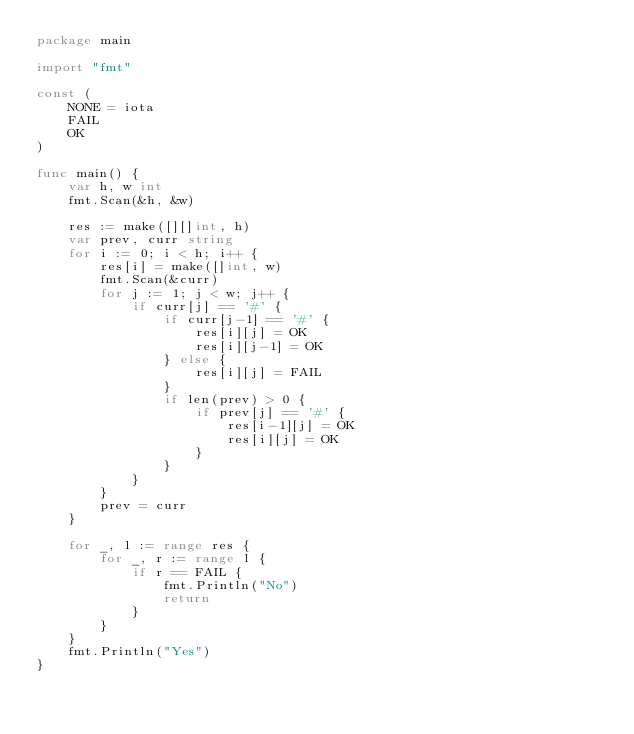<code> <loc_0><loc_0><loc_500><loc_500><_Go_>package main

import "fmt"

const (
	NONE = iota
	FAIL
	OK
)

func main() {
	var h, w int
	fmt.Scan(&h, &w)

	res := make([][]int, h)
	var prev, curr string
	for i := 0; i < h; i++ {
		res[i] = make([]int, w)
		fmt.Scan(&curr)
		for j := 1; j < w; j++ {
			if curr[j] == '#' {
				if curr[j-1] == '#' {
					res[i][j] = OK
					res[i][j-1] = OK
				} else {
					res[i][j] = FAIL
				}
				if len(prev) > 0 {
					if prev[j] == '#' {
						res[i-1][j] = OK
						res[i][j] = OK
					}
				}
			}
		}
		prev = curr
	}

	for _, l := range res {
		for _, r := range l {
			if r == FAIL {
				fmt.Println("No")
				return
			}
		}
	}
	fmt.Println("Yes")
}</code> 